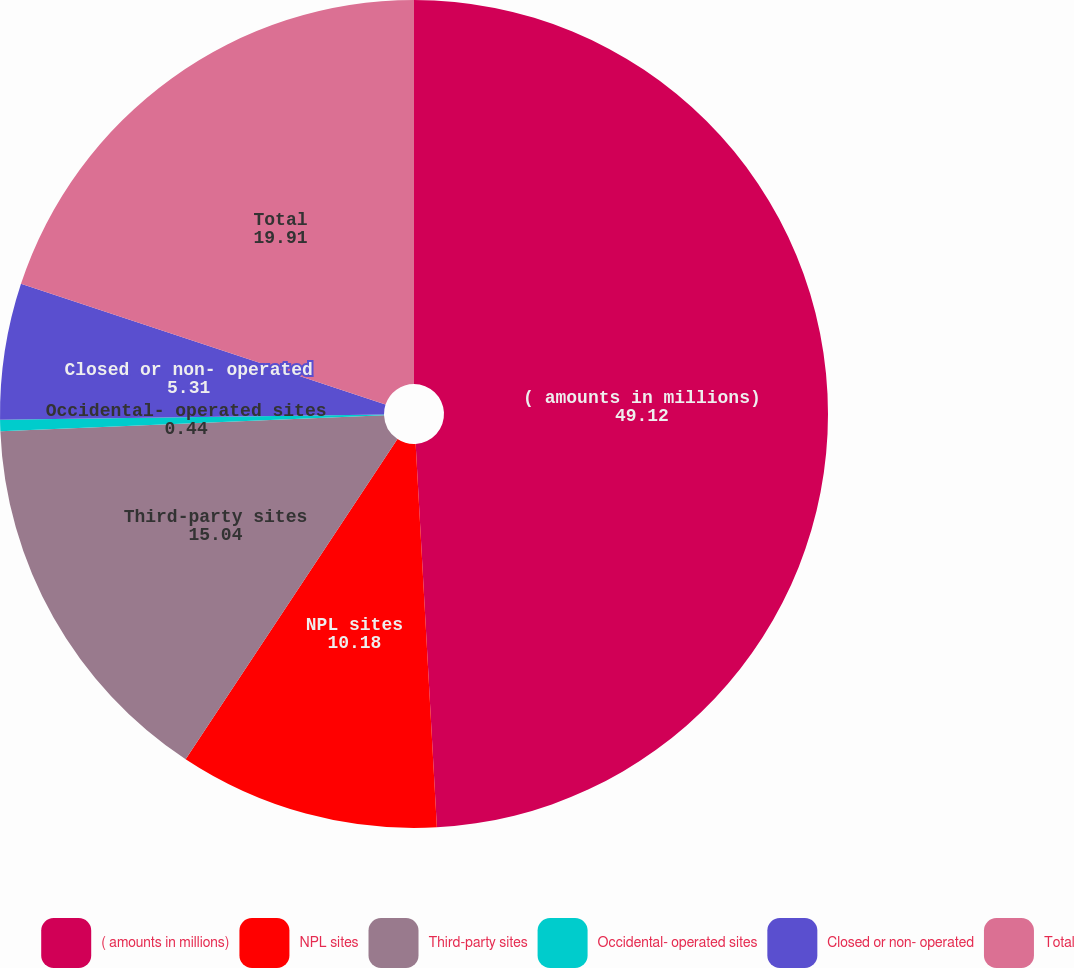<chart> <loc_0><loc_0><loc_500><loc_500><pie_chart><fcel>( amounts in millions)<fcel>NPL sites<fcel>Third-party sites<fcel>Occidental- operated sites<fcel>Closed or non- operated<fcel>Total<nl><fcel>49.12%<fcel>10.18%<fcel>15.04%<fcel>0.44%<fcel>5.31%<fcel>19.91%<nl></chart> 